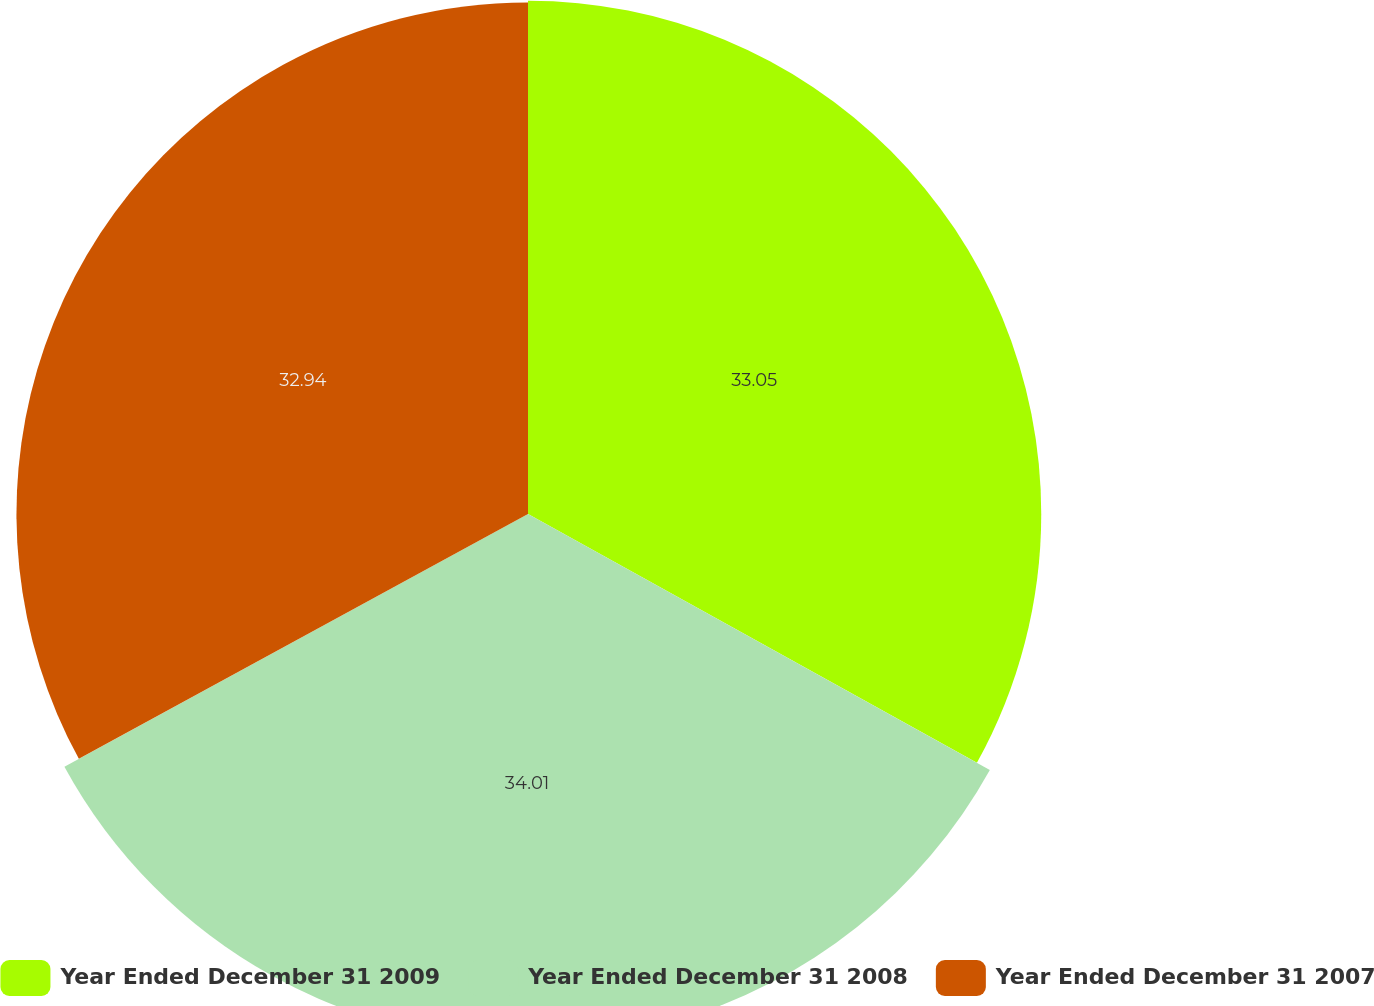Convert chart to OTSL. <chart><loc_0><loc_0><loc_500><loc_500><pie_chart><fcel>Year Ended December 31 2009<fcel>Year Ended December 31 2008<fcel>Year Ended December 31 2007<nl><fcel>33.05%<fcel>34.0%<fcel>32.94%<nl></chart> 